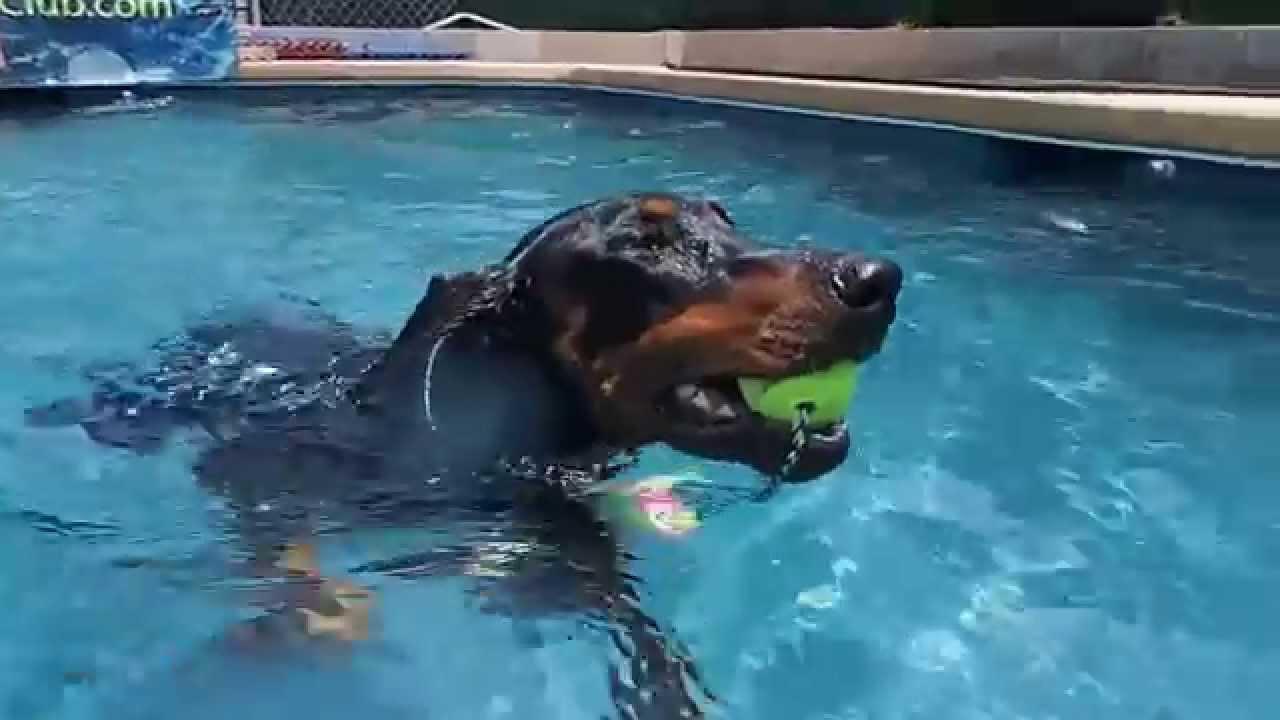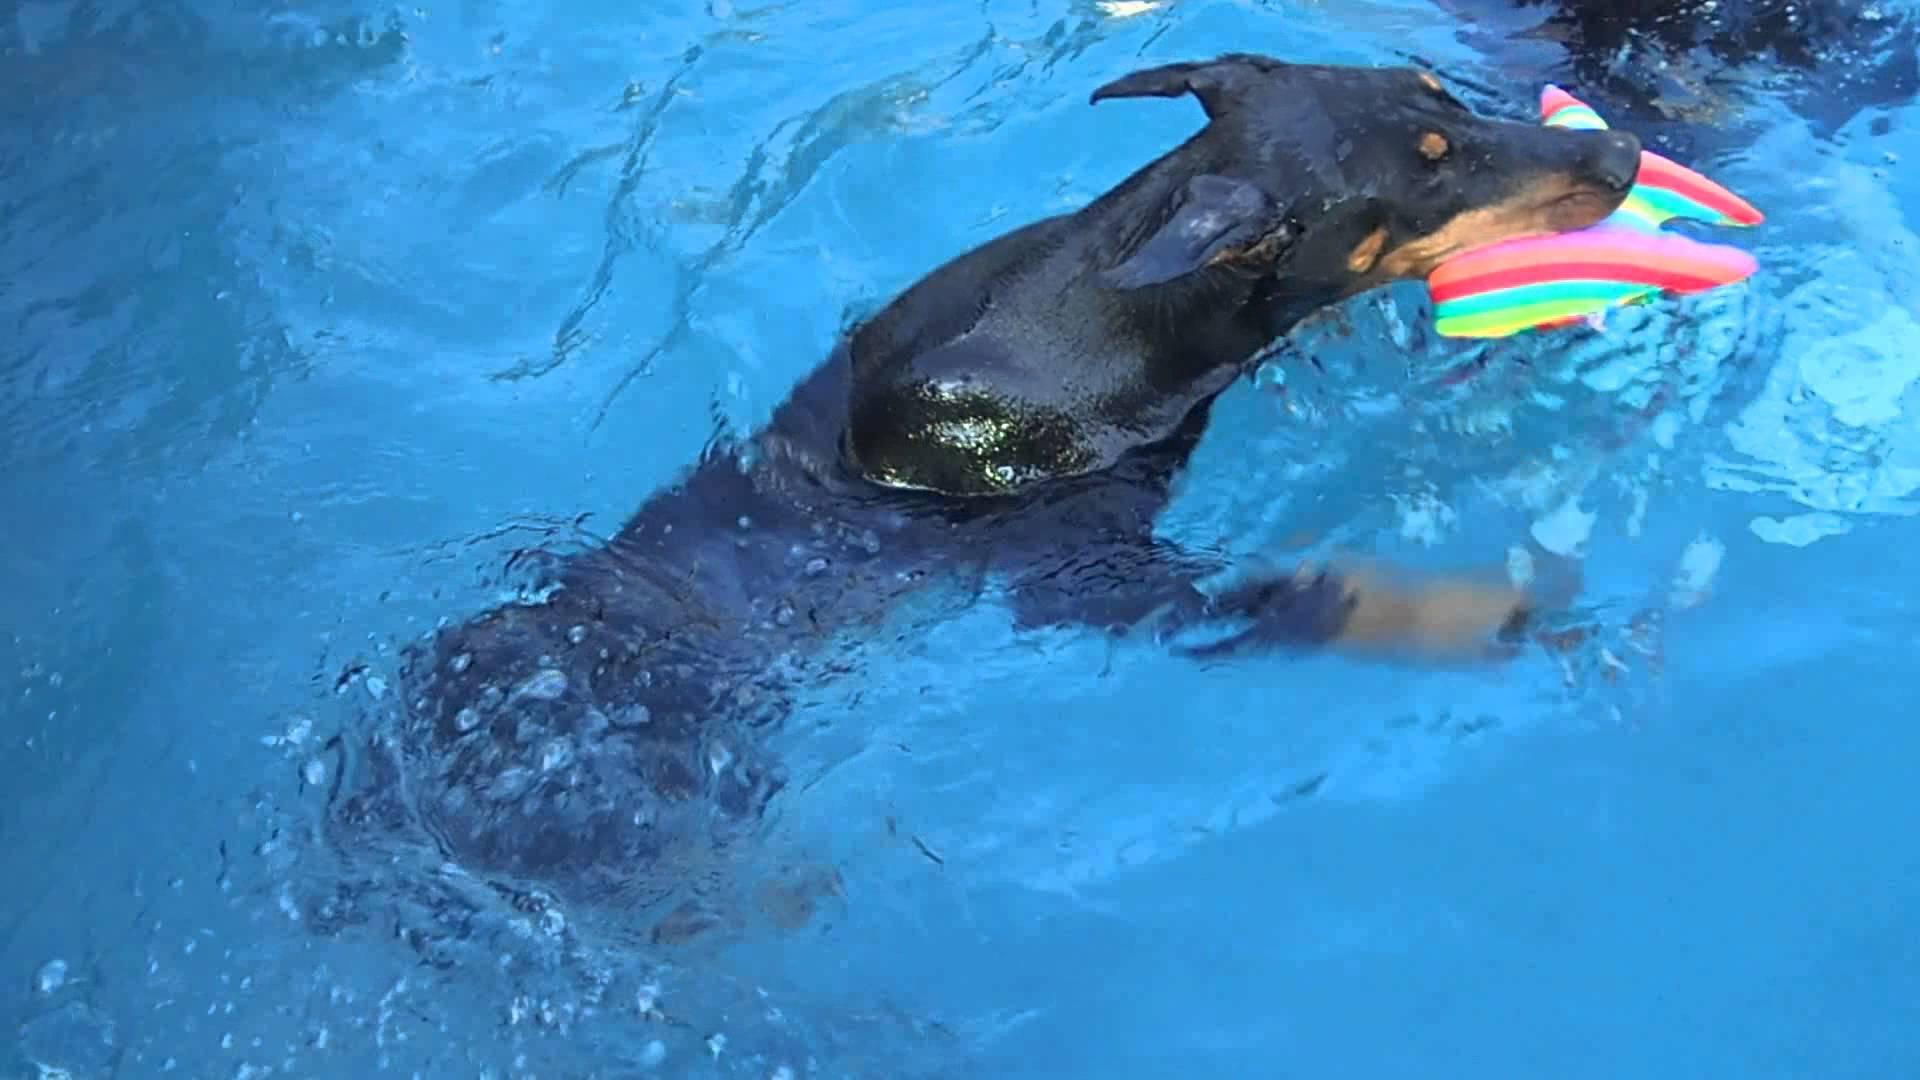The first image is the image on the left, the second image is the image on the right. For the images shown, is this caption "Both dogs are swimming in a pool and neither is sitting on a float." true? Answer yes or no. Yes. The first image is the image on the left, the second image is the image on the right. Examine the images to the left and right. Is the description "A man is in a pool interacting with a doberman in one image, and the other shows a doberman by itself in water." accurate? Answer yes or no. No. 